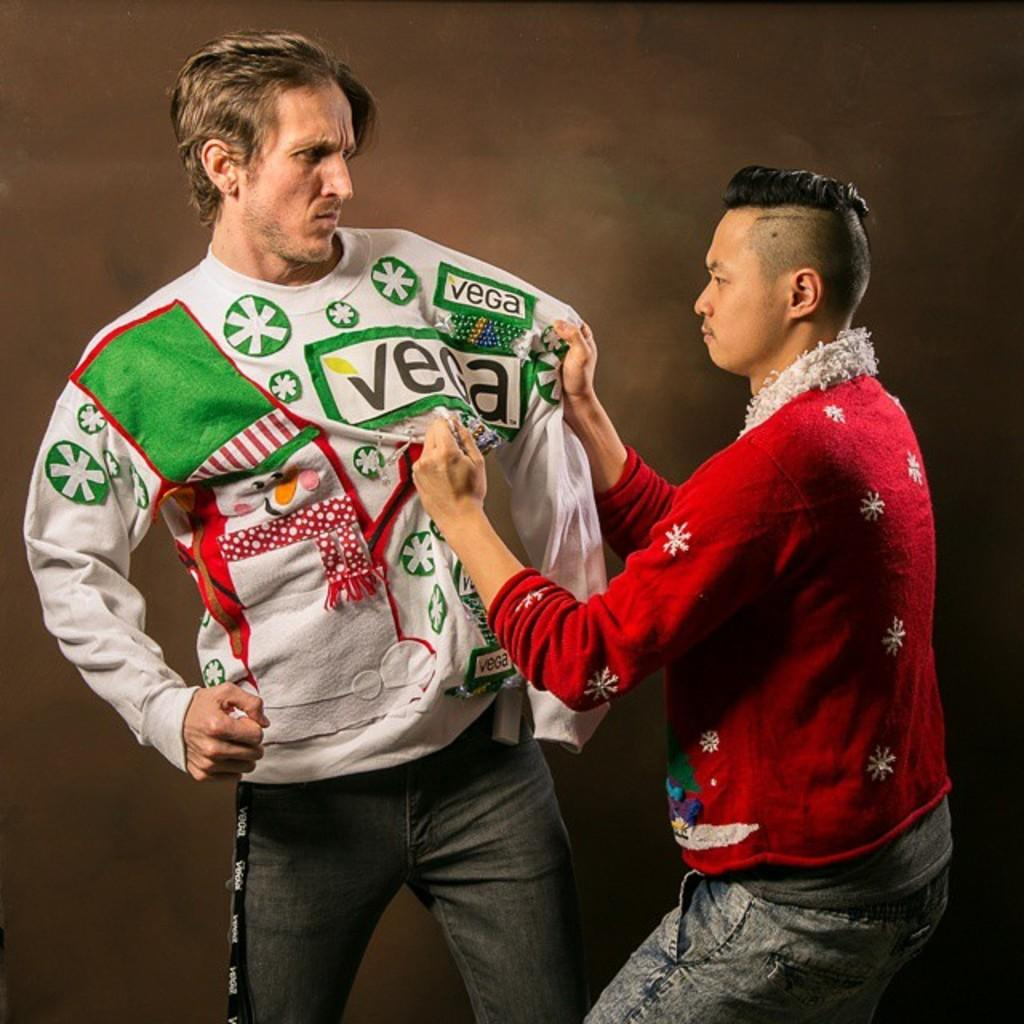<image>
Write a terse but informative summary of the picture. a person trying to adjust a venar jacket on 